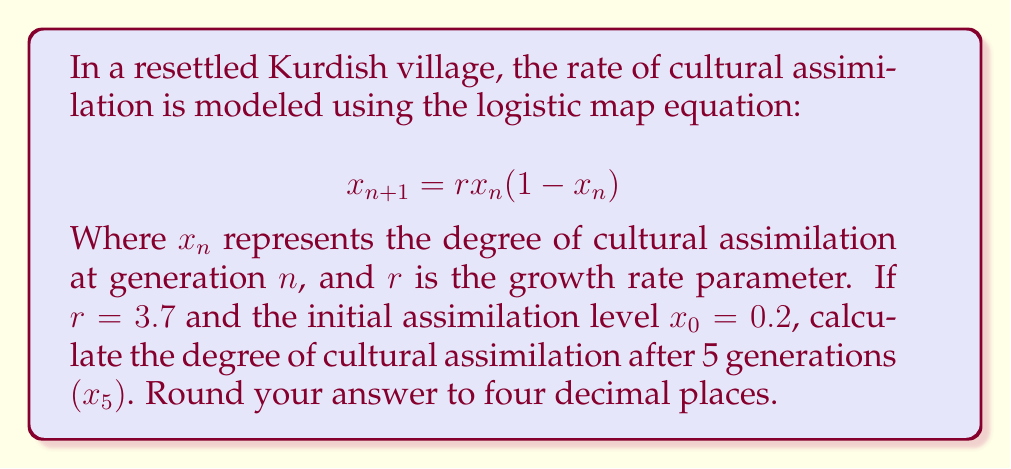Provide a solution to this math problem. To solve this problem, we need to iterate the logistic map equation for 5 generations:

1. Start with $x_0 = 0.2$ and $r = 3.7$

2. Calculate $x_1$:
   $$x_1 = 3.7 \cdot 0.2 \cdot (1-0.2) = 0.592$$

3. Calculate $x_2$:
   $$x_2 = 3.7 \cdot 0.592 \cdot (1-0.592) = 0.8930$$

4. Calculate $x_3$:
   $$x_3 = 3.7 \cdot 0.8930 \cdot (1-0.8930) = 0.3542$$

5. Calculate $x_4$:
   $$x_4 = 3.7 \cdot 0.3542 \cdot (1-0.3542) = 0.8455$$

6. Calculate $x_5$:
   $$x_5 = 3.7 \cdot 0.8455 \cdot (1-0.8455) = 0.4845$$

7. Round the result to four decimal places: 0.4845

This demonstrates the chaotic behavior of cultural assimilation in the resettled community, as the values fluctuate unpredictably over generations.
Answer: 0.4845 